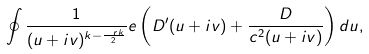<formula> <loc_0><loc_0><loc_500><loc_500>\oint \frac { 1 } { ( u + i v ) ^ { k - \frac { \ r k } { 2 } } } e \left ( D ^ { \prime } ( u + i v ) + \frac { D } { c ^ { 2 } ( u + i v ) } \right ) d u ,</formula> 